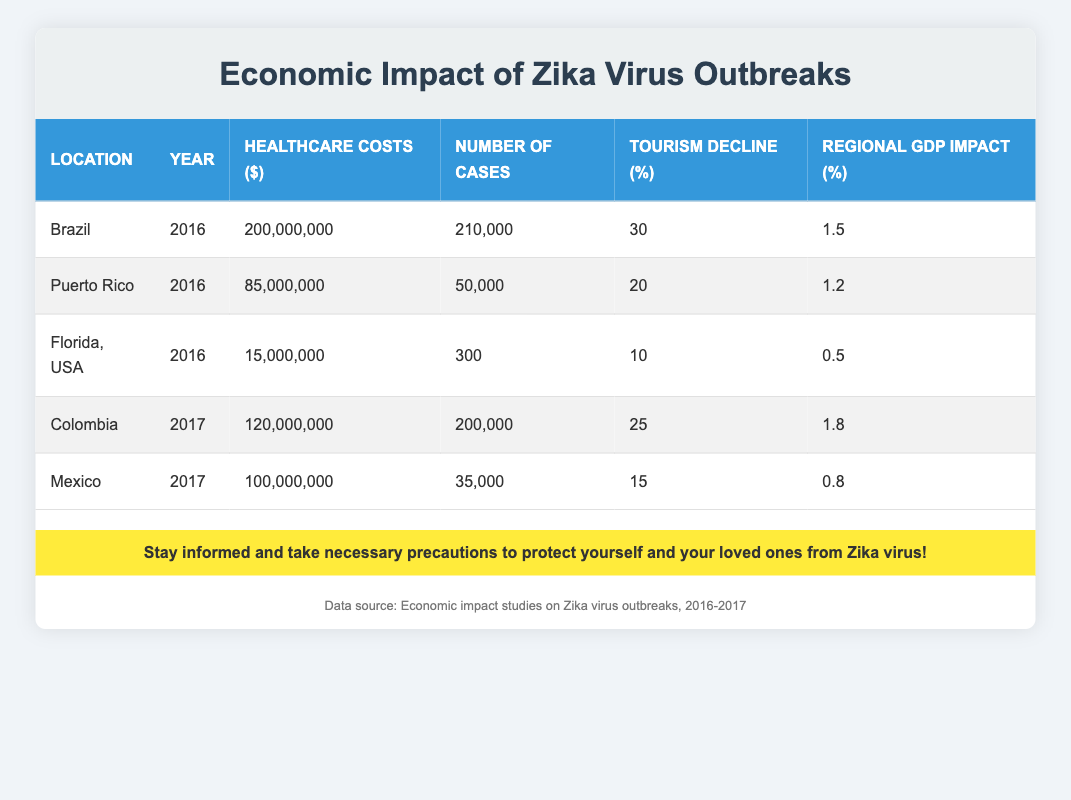What were the healthcare costs in Brazil during the Zika outbreak in 2016? The table shows that Brazil had healthcare costs of 200,000,000 in 2016. This figure is listed directly in the row for Brazil under the 'Healthcare Costs' column.
Answer: 200,000,000 How many cases were reported in Puerto Rico in 2016? According to the table, Puerto Rico had 50,000 reported cases in 2016, as found in the 'Number of Cases' column for that location and year.
Answer: 50,000 Which location experienced the highest percentage decline in tourism in 2016? In the table, Brazil shows a tourism decline percentage of 30, which is higher than Puerto Rico (20) and Florida (10) for the year 2016. Therefore, Brazil experienced the highest decline.
Answer: Brazil What is the average healthcare cost among the locations listed for 2016? To find the average, add the healthcare costs for the three locations in 2016: 200,000,000 (Brazil) + 85,000,000 (Puerto Rico) + 15,000,000 (Florida) = 300,000,000. Divide by the number of locations (3): 300,000,000 / 3 = 100,000,000.
Answer: 100,000,000 Did Mexico experience a higher or lower tourism decline than Colombia in 2017? The tourism decline for Mexico is 15%, while for Colombia it is 25%. Since 15% is lower than 25%, Mexico experienced a lower tourism decline than Colombia in 2017.
Answer: Lower What was the overall regional GDP impact in Colombia in 2017 compared to Florida in 2016? Colombia had a regional GDP impact of 1.8% in 2017, while Florida had 0.5% in 2016. Since 1.8 is greater than 0.5, Colombia had a higher regional GDP impact compared to Florida.
Answer: Higher How many total cases were reported in the years 2016 and 2017 combined across all locations? Adding the cases: Brazil (210,000) + Puerto Rico (50,000) + Florida (300) + Colombia (200,000) + Mexico (35,000) gives a total of 495,300 cases. Thus, the total cases reported in the two years combined is 495,300.
Answer: 495,300 Was there any location with a regional GDP impact of less than 1% in the table? The table shows that Florida (0.5%) and Mexico (0.8%) both have a regional GDP impact of less than 1%. Therefore, the answer is yes, there were locations with a lower impact.
Answer: Yes 